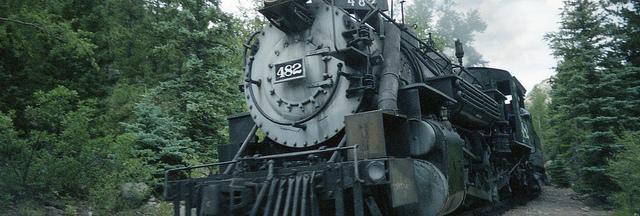How many tracks are there?
Short answer required. 1. What number is on the train?
Concise answer only. 482. Is this a steam train?
Quick response, please. Yes. 